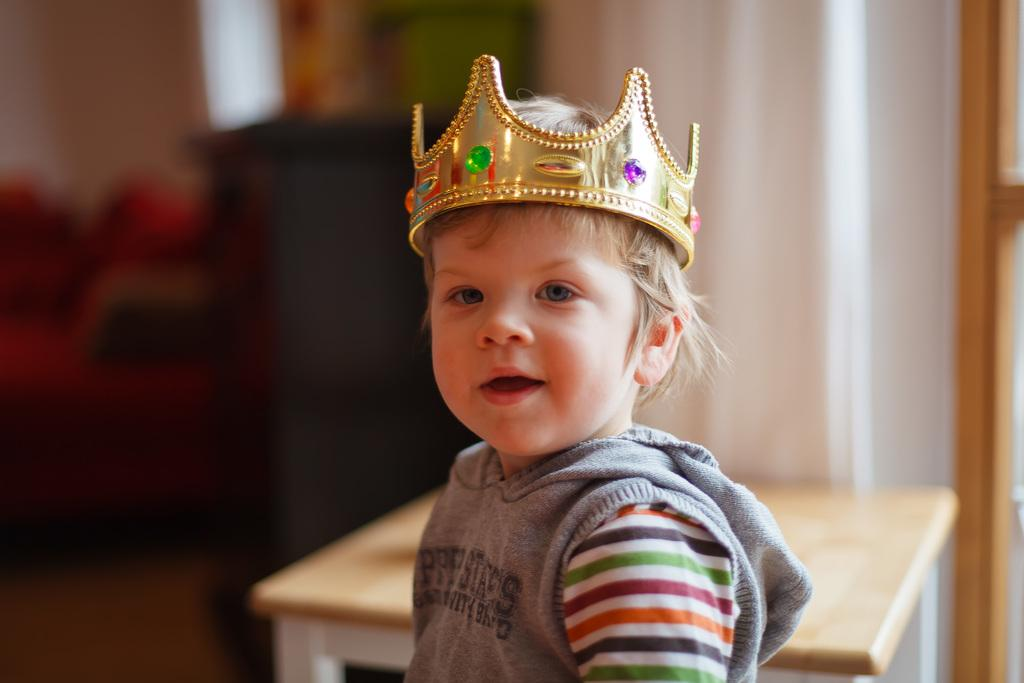What is the boy wearing in the image? The boy is wearing a crown in the image. Can you describe the background of the image? The background is blurred in the image. What is one object present in the image? There is a table in the image. What type of structure can be seen in the image? There is a wall in the image. What type of science experiment is being conducted on the table in the image? There is no science experiment or any indication of one being conducted in the image. 